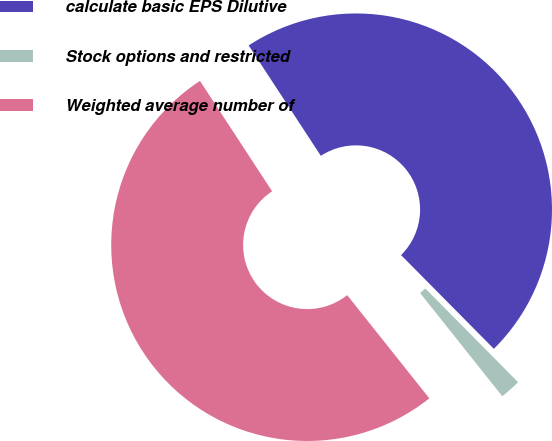Convert chart to OTSL. <chart><loc_0><loc_0><loc_500><loc_500><pie_chart><fcel>calculate basic EPS Dilutive<fcel>Stock options and restricted<fcel>Weighted average number of<nl><fcel>46.8%<fcel>1.72%<fcel>51.48%<nl></chart> 